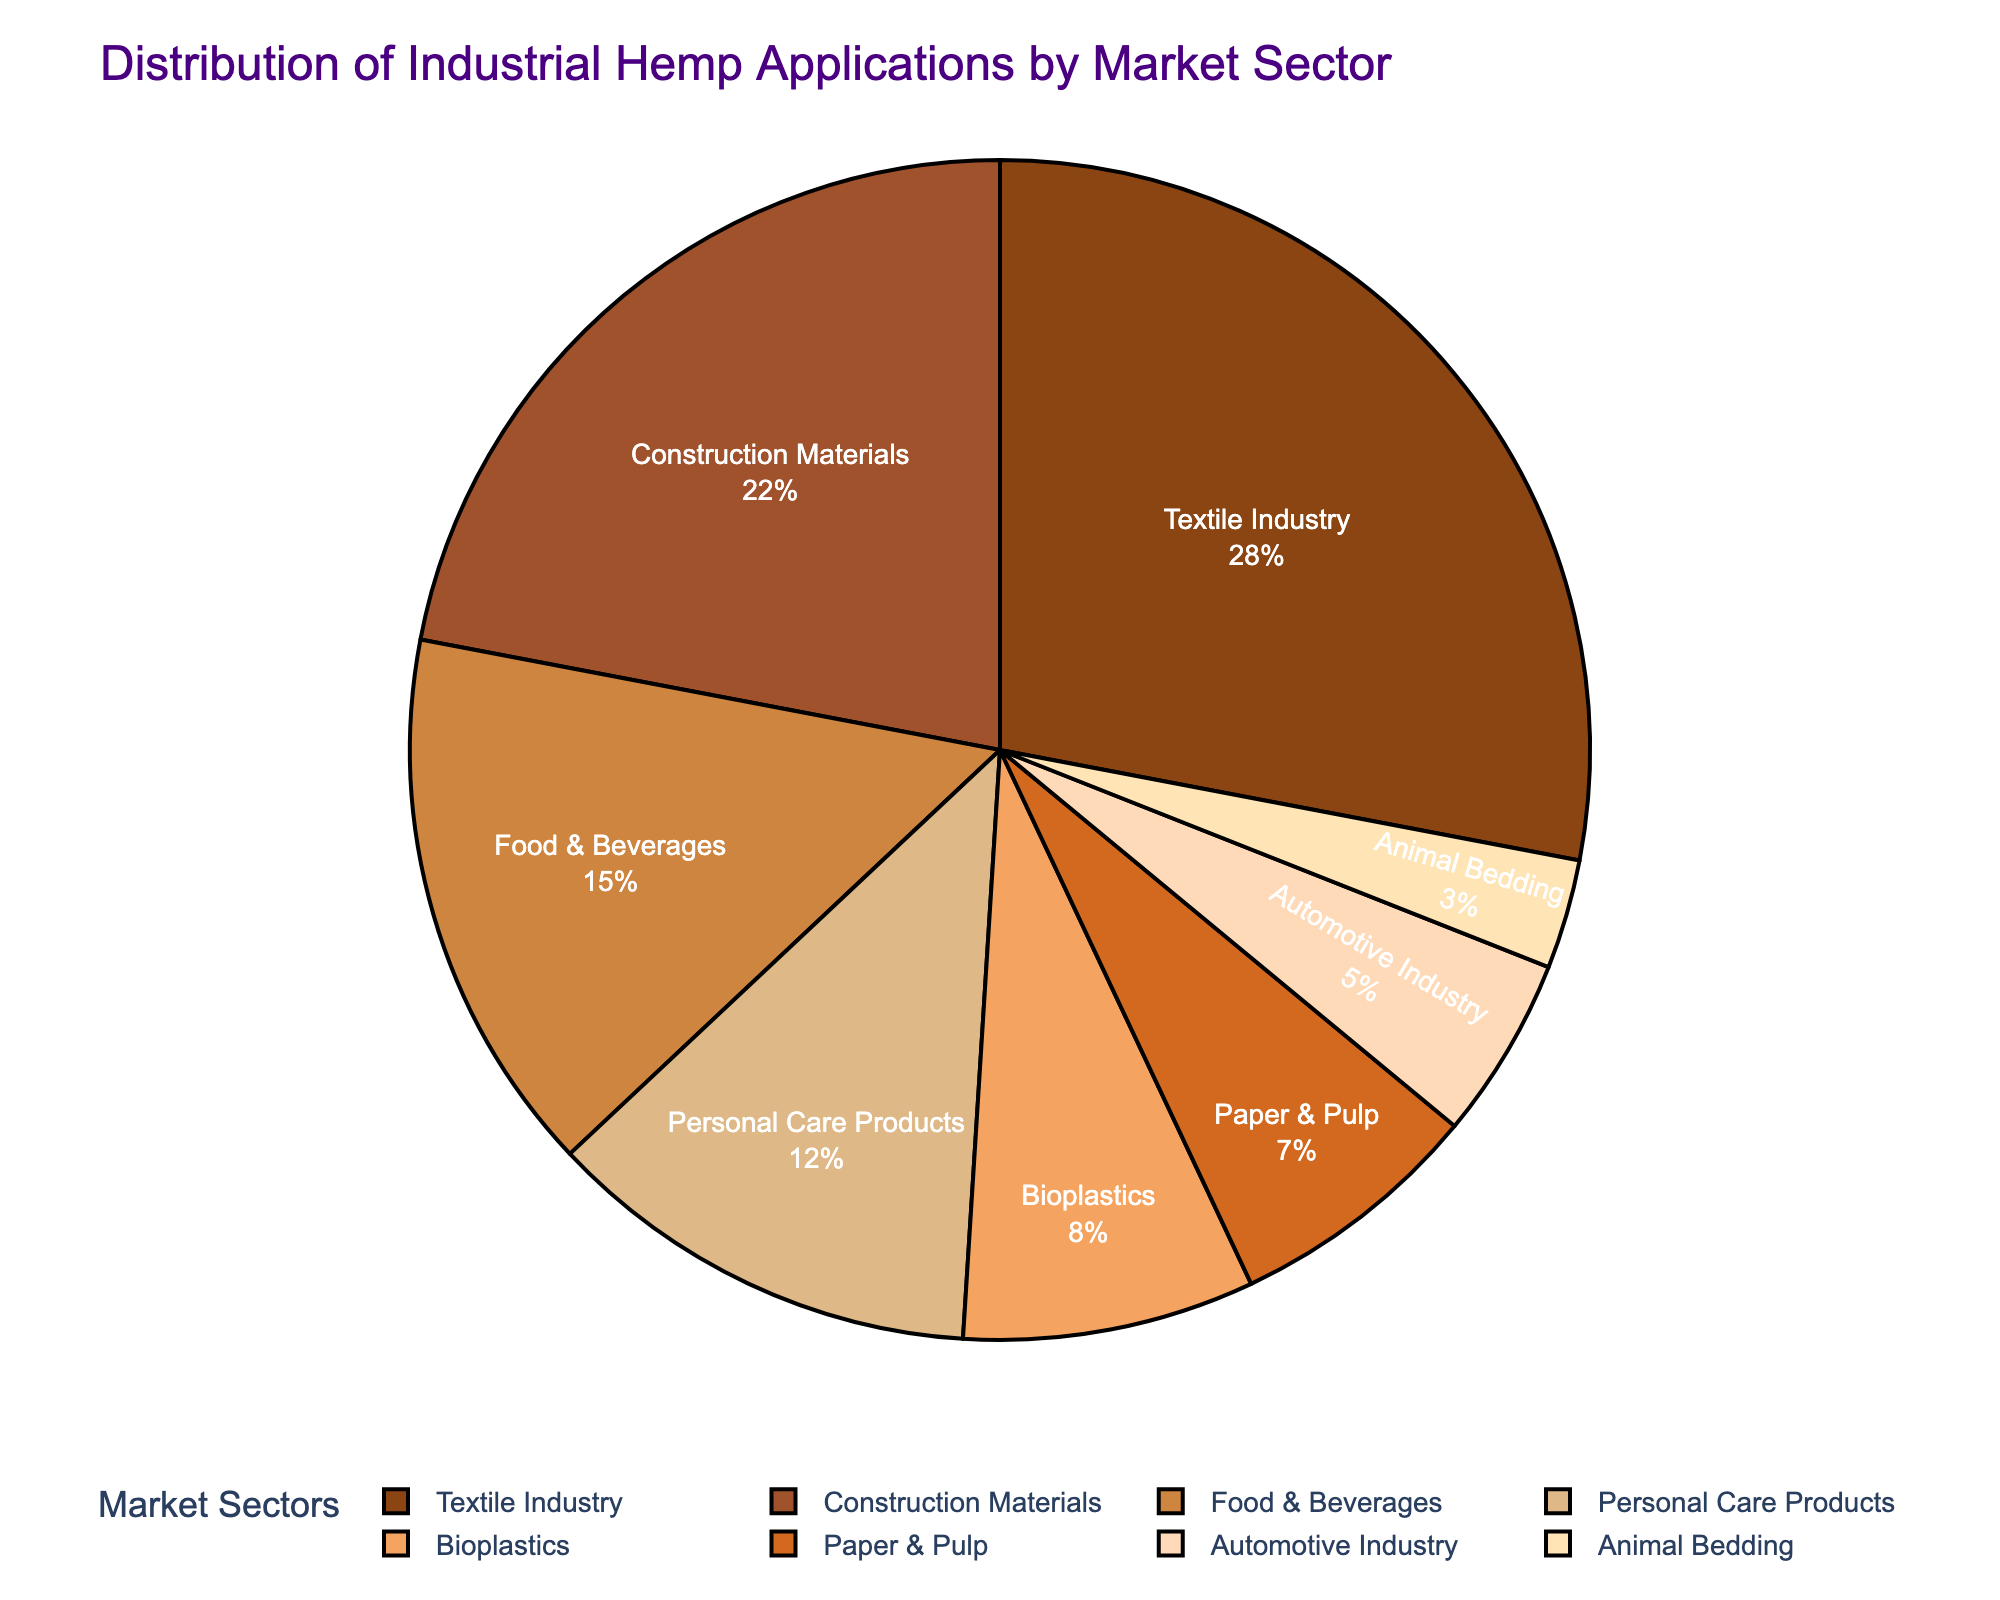Which market sector has the highest percentage? The pie chart shows the proportion of different market sectors for industrial hemp applications. The Textile Industry sector occupies the largest segment.
Answer: Textile Industry What is the combined percentage of the Automotive Industry and Animal Bedding sectors? According to the pie chart, the Automotive Industry has 5% and Animal Bedding has 3%. Adding these up, 5 + 3 = 8%.
Answer: 8% Which sector has a higher percentage: Construction Materials or Food & Beverages? The chart indicates that Construction Materials has 22% while Food & Beverages has 15%. Since 22% is greater than 15%, Construction Materials has a higher percentage.
Answer: Construction Materials How many sectors have a percentage lower than 10%? The sectors with percentages lower than 10% are Bioplastics (8%), Paper & Pulp (7%), Automotive Industry (5%), and Animal Bedding (3%). Hence, there are four such sectors.
Answer: 4 What is the percentage difference between the Textile Industry and Personal Care Products sectors? The Textile Industry has 28% and Personal Care Products have 12%. The difference is 28 - 12 = 16%.
Answer: 16% Which sector uses the lightest shade of brown in the color palette? The color palette ranges from darkest to lightest. The lightest brown corresponds to the smallest percentage, which is Animal Bedding at 3%.
Answer: Animal Bedding What is the total percentage of the top three market sectors? The top three market sectors are Textile Industry (28%), Construction Materials (22%), and Food & Beverages (15%). Adding these gives 28 + 22 + 15 = 65%.
Answer: 65% Is the percentage of Bioplastics higher or lower than the percentage of Paper & Pulp? Bioplastics are 8%, while Paper & Pulp is 7%. Hence, Bioplastics has a higher percentage than Paper & Pulp.
Answer: Higher What is the average percentage of the sectors with at least 10%? The sectors with at least 10% are Textile Industry (28%), Construction Materials (22%), Food & Beverages (15%), and Personal Care Products (12%). The sum of these percentages is 28 + 22 + 15 + 12 = 77%. The average is 77% / 4 = 19.25%.
Answer: 19.25% How much more significant is the Textile Industry sector compared to the Automotive Industry sector in percentage terms? The Textile Industry is 28% and the Automotive Industry is 5%. The difference is 28 - 5 = 23%. Therefore, the Textile Industry sector is 23 percentage points more significant than the Automotive Industry.
Answer: 23% 